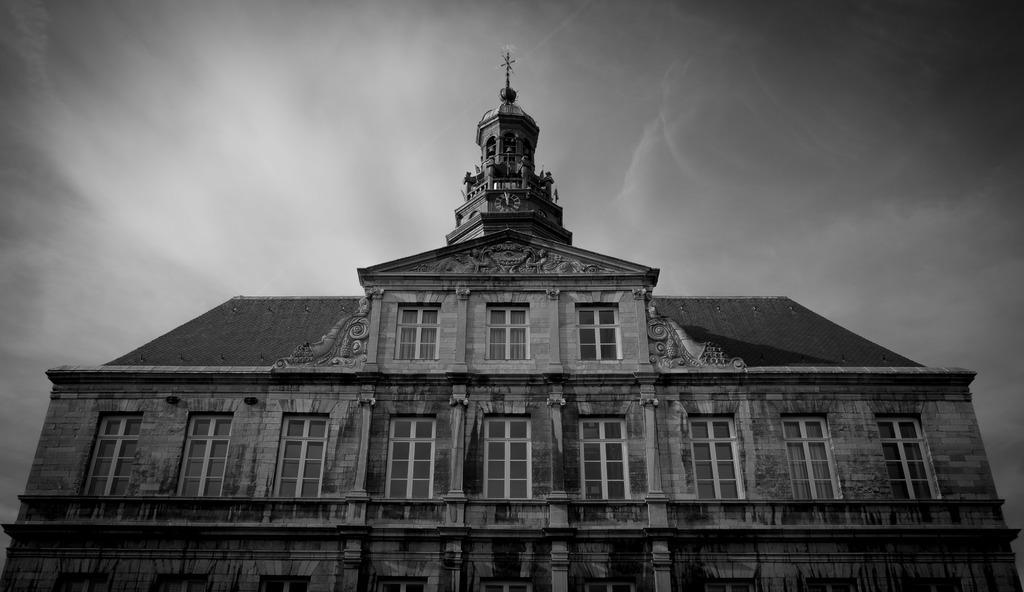Can you describe this image briefly? This is a black and white image. In this image we can see building and statues on the top of it. In the background there is sky with clouds. 